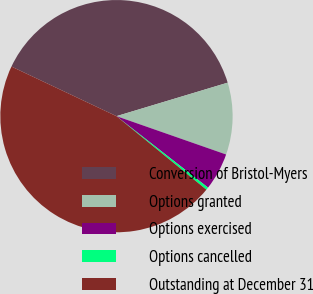Convert chart to OTSL. <chart><loc_0><loc_0><loc_500><loc_500><pie_chart><fcel>Conversion of Bristol-Myers<fcel>Options granted<fcel>Options exercised<fcel>Options cancelled<fcel>Outstanding at December 31<nl><fcel>38.32%<fcel>10.01%<fcel>5.19%<fcel>0.37%<fcel>46.11%<nl></chart> 